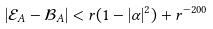<formula> <loc_0><loc_0><loc_500><loc_500>| \mathcal { E } _ { A } - \mathcal { B } _ { A } | < r ( 1 - | \alpha | ^ { 2 } ) + r ^ { - 2 0 0 }</formula> 